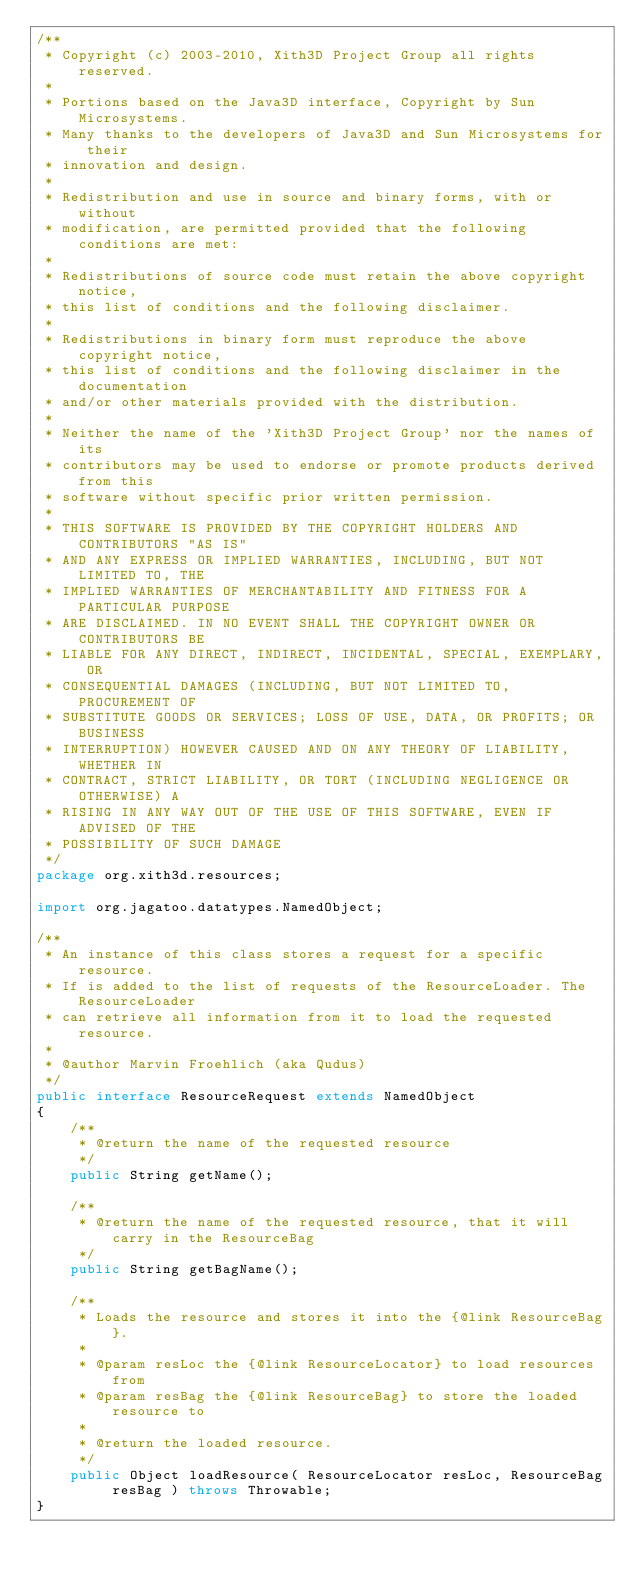<code> <loc_0><loc_0><loc_500><loc_500><_Java_>/**
 * Copyright (c) 2003-2010, Xith3D Project Group all rights reserved.
 * 
 * Portions based on the Java3D interface, Copyright by Sun Microsystems.
 * Many thanks to the developers of Java3D and Sun Microsystems for their
 * innovation and design.
 * 
 * Redistribution and use in source and binary forms, with or without
 * modification, are permitted provided that the following conditions are met:
 * 
 * Redistributions of source code must retain the above copyright notice,
 * this list of conditions and the following disclaimer.
 * 
 * Redistributions in binary form must reproduce the above copyright notice,
 * this list of conditions and the following disclaimer in the documentation
 * and/or other materials provided with the distribution.
 * 
 * Neither the name of the 'Xith3D Project Group' nor the names of its
 * contributors may be used to endorse or promote products derived from this
 * software without specific prior written permission.
 * 
 * THIS SOFTWARE IS PROVIDED BY THE COPYRIGHT HOLDERS AND CONTRIBUTORS "AS IS"
 * AND ANY EXPRESS OR IMPLIED WARRANTIES, INCLUDING, BUT NOT LIMITED TO, THE
 * IMPLIED WARRANTIES OF MERCHANTABILITY AND FITNESS FOR A PARTICULAR PURPOSE
 * ARE DISCLAIMED. IN NO EVENT SHALL THE COPYRIGHT OWNER OR CONTRIBUTORS BE
 * LIABLE FOR ANY DIRECT, INDIRECT, INCIDENTAL, SPECIAL, EXEMPLARY, OR
 * CONSEQUENTIAL DAMAGES (INCLUDING, BUT NOT LIMITED TO, PROCUREMENT OF
 * SUBSTITUTE GOODS OR SERVICES; LOSS OF USE, DATA, OR PROFITS; OR BUSINESS
 * INTERRUPTION) HOWEVER CAUSED AND ON ANY THEORY OF LIABILITY, WHETHER IN
 * CONTRACT, STRICT LIABILITY, OR TORT (INCLUDING NEGLIGENCE OR OTHERWISE) A
 * RISING IN ANY WAY OUT OF THE USE OF THIS SOFTWARE, EVEN IF ADVISED OF THE
 * POSSIBILITY OF SUCH DAMAGE
 */
package org.xith3d.resources;

import org.jagatoo.datatypes.NamedObject;

/**
 * An instance of this class stores a request for a specific resource.
 * If is added to the list of requests of the ResourceLoader. The ResourceLoader
 * can retrieve all information from it to load the requested resource.
 * 
 * @author Marvin Froehlich (aka Qudus)
 */
public interface ResourceRequest extends NamedObject
{
    /**
     * @return the name of the requested resource
     */
    public String getName();
    
    /**
     * @return the name of the requested resource, that it will carry in the ResourceBag
     */
    public String getBagName();
    
    /**
     * Loads the resource and stores it into the {@link ResourceBag}.
     * 
     * @param resLoc the {@link ResourceLocator} to load resources from
     * @param resBag the {@link ResourceBag} to store the loaded resource to
     * 
     * @return the loaded resource.
     */
    public Object loadResource( ResourceLocator resLoc, ResourceBag resBag ) throws Throwable;
}
</code> 